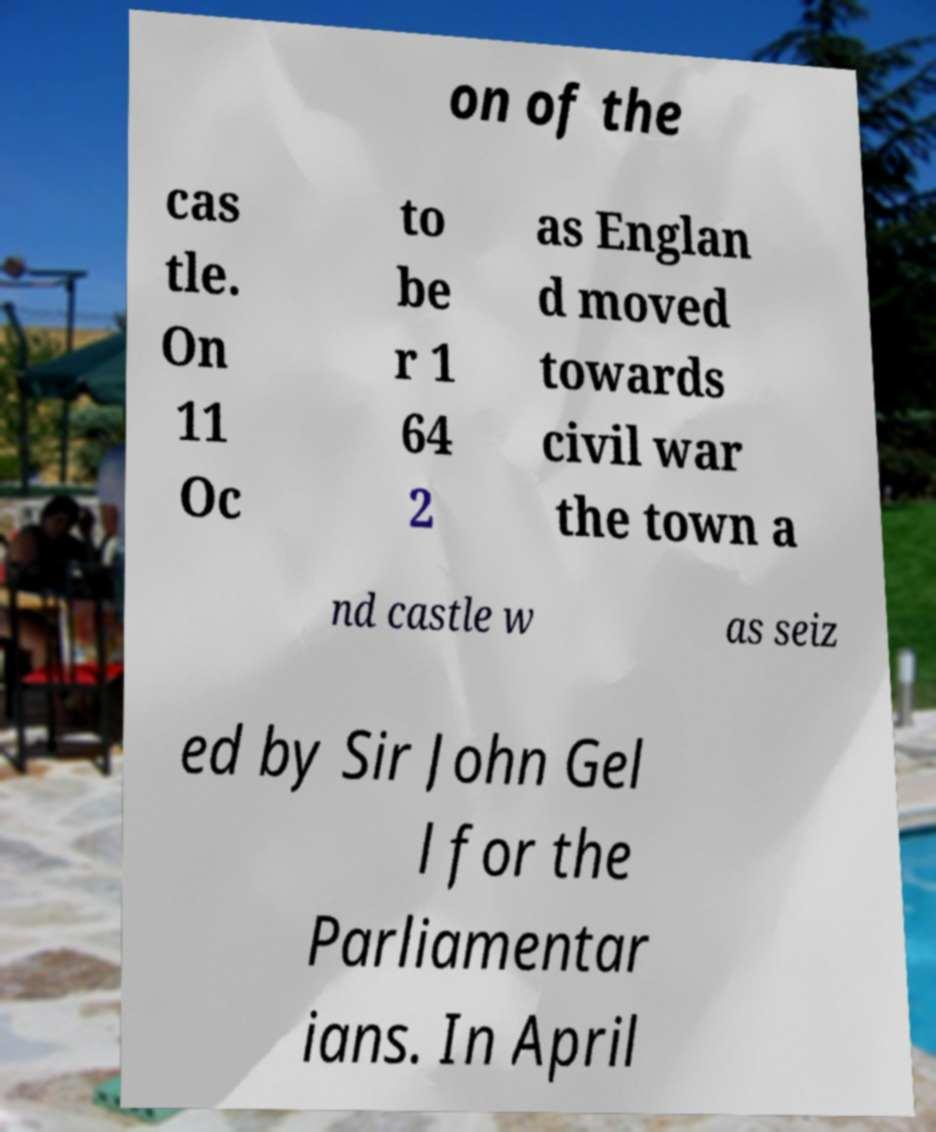I need the written content from this picture converted into text. Can you do that? on of the cas tle. On 11 Oc to be r 1 64 2 as Englan d moved towards civil war the town a nd castle w as seiz ed by Sir John Gel l for the Parliamentar ians. In April 